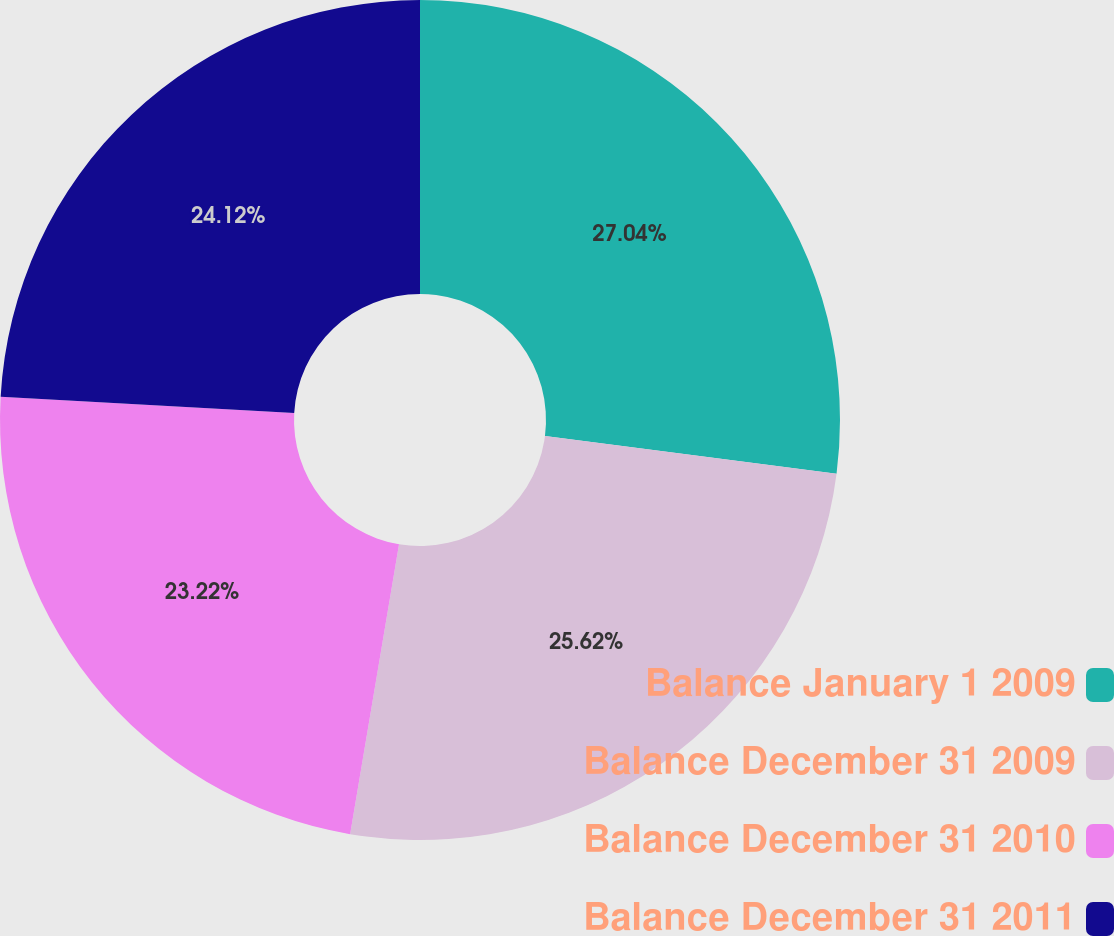Convert chart to OTSL. <chart><loc_0><loc_0><loc_500><loc_500><pie_chart><fcel>Balance January 1 2009<fcel>Balance December 31 2009<fcel>Balance December 31 2010<fcel>Balance December 31 2011<nl><fcel>27.04%<fcel>25.62%<fcel>23.22%<fcel>24.12%<nl></chart> 